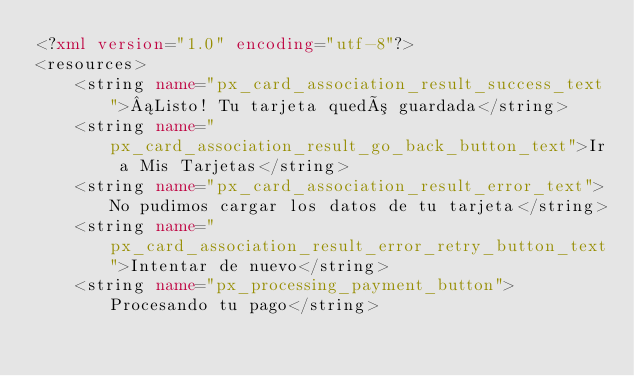Convert code to text. <code><loc_0><loc_0><loc_500><loc_500><_XML_><?xml version="1.0" encoding="utf-8"?>
<resources>
    <string name="px_card_association_result_success_text">¡Listo! Tu tarjeta quedó guardada</string>
    <string name="px_card_association_result_go_back_button_text">Ir a Mis Tarjetas</string>
    <string name="px_card_association_result_error_text">No pudimos cargar los datos de tu tarjeta</string>
    <string name="px_card_association_result_error_retry_button_text">Intentar de nuevo</string>
    <string name="px_processing_payment_button">Procesando tu pago</string></code> 